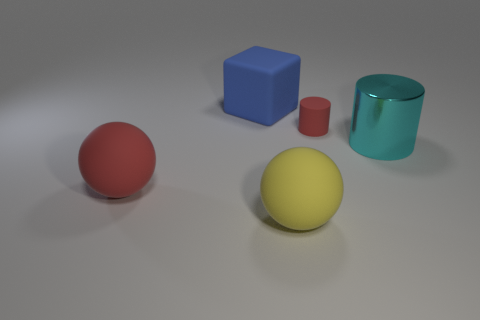Subtract all cubes. How many objects are left? 4 Subtract all red cylinders. How many cylinders are left? 1 Subtract 2 balls. How many balls are left? 0 Subtract all blue cylinders. How many yellow spheres are left? 1 Subtract all large yellow matte cylinders. Subtract all big yellow spheres. How many objects are left? 4 Add 4 big things. How many big things are left? 8 Add 1 big purple things. How many big purple things exist? 1 Add 1 big red rubber things. How many objects exist? 6 Subtract 1 red balls. How many objects are left? 4 Subtract all brown cylinders. Subtract all blue cubes. How many cylinders are left? 2 